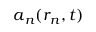<formula> <loc_0><loc_0><loc_500><loc_500>a _ { n } ( r _ { \, n } , t )</formula> 